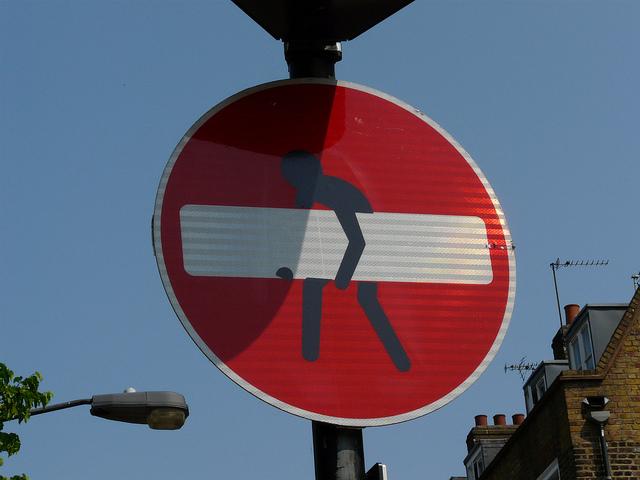What two word phrase does the picture mean?
Be succinct. No crossing. What color is the sign?
Concise answer only. Red. How many clouds are in the sky?
Quick response, please. 0. What shape is inside the circle?
Quick response, please. Rectangle. What is to the left of the sign?
Keep it brief. Streetlight. 